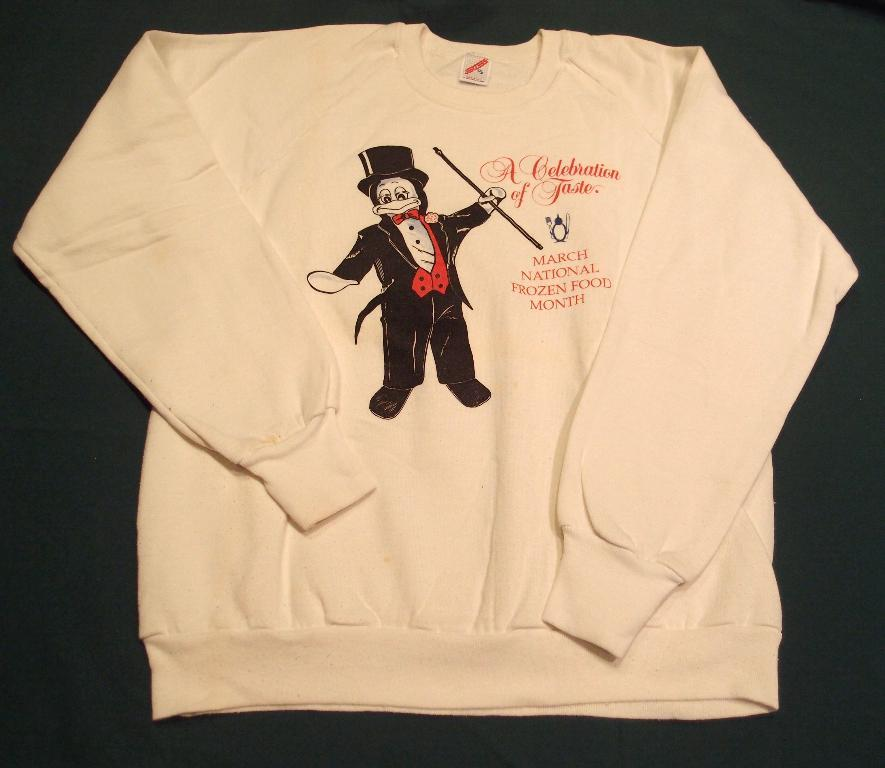What type of clothing item is visible in the image? There is a T-shirt in the image. What is depicted on the T-shirt? The T-shirt has an image on it. Are there any words on the T-shirt? Yes, the T-shirt has text on it. What type of riddle is written on the notebook in the image? There is no notebook present in the image, and therefore no riddle can be found. 